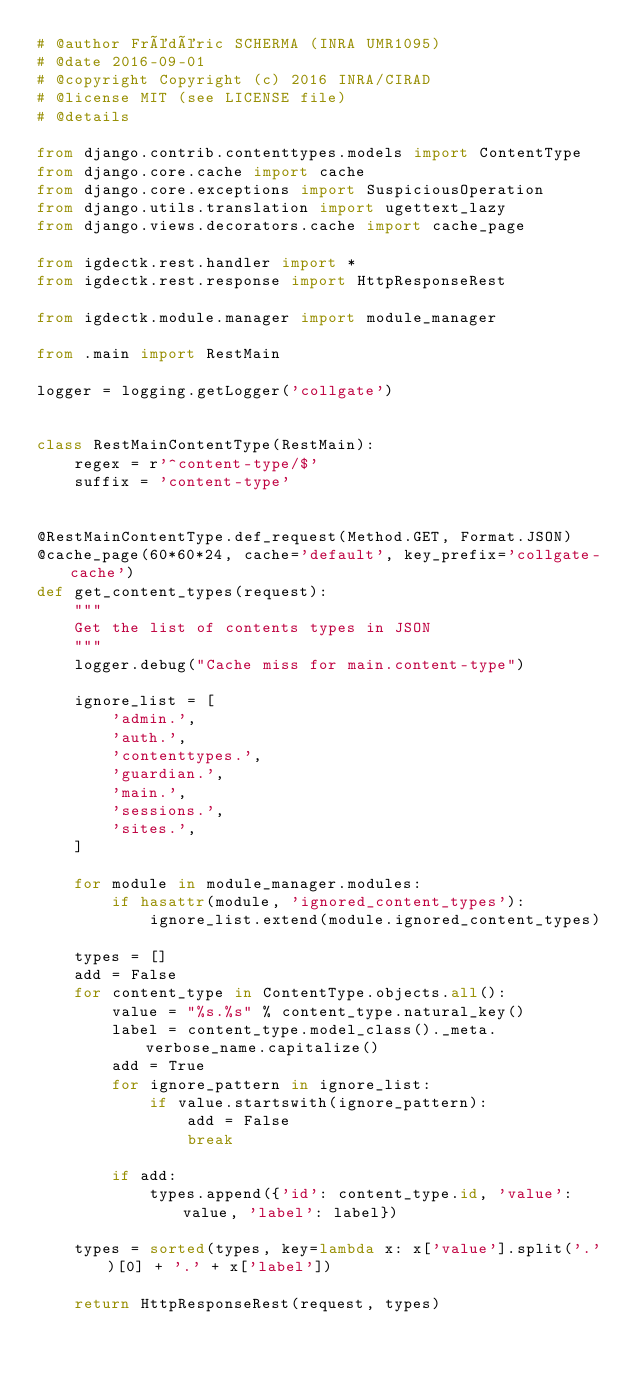Convert code to text. <code><loc_0><loc_0><loc_500><loc_500><_Python_># @author Frédéric SCHERMA (INRA UMR1095)
# @date 2016-09-01
# @copyright Copyright (c) 2016 INRA/CIRAD
# @license MIT (see LICENSE file)
# @details 

from django.contrib.contenttypes.models import ContentType
from django.core.cache import cache
from django.core.exceptions import SuspiciousOperation
from django.utils.translation import ugettext_lazy
from django.views.decorators.cache import cache_page

from igdectk.rest.handler import *
from igdectk.rest.response import HttpResponseRest

from igdectk.module.manager import module_manager

from .main import RestMain

logger = logging.getLogger('collgate')


class RestMainContentType(RestMain):
    regex = r'^content-type/$'
    suffix = 'content-type'


@RestMainContentType.def_request(Method.GET, Format.JSON)
@cache_page(60*60*24, cache='default', key_prefix='collgate-cache')
def get_content_types(request):
    """
    Get the list of contents types in JSON
    """
    logger.debug("Cache miss for main.content-type")

    ignore_list = [
        'admin.',
        'auth.',
        'contenttypes.',
        'guardian.',
        'main.',
        'sessions.',
        'sites.',
    ]

    for module in module_manager.modules:
        if hasattr(module, 'ignored_content_types'):
            ignore_list.extend(module.ignored_content_types)

    types = []
    add = False
    for content_type in ContentType.objects.all():
        value = "%s.%s" % content_type.natural_key()
        label = content_type.model_class()._meta.verbose_name.capitalize()
        add = True
        for ignore_pattern in ignore_list:
            if value.startswith(ignore_pattern):
                add = False
                break

        if add:
            types.append({'id': content_type.id, 'value': value, 'label': label})

    types = sorted(types, key=lambda x: x['value'].split('.')[0] + '.' + x['label'])

    return HttpResponseRest(request, types)
</code> 